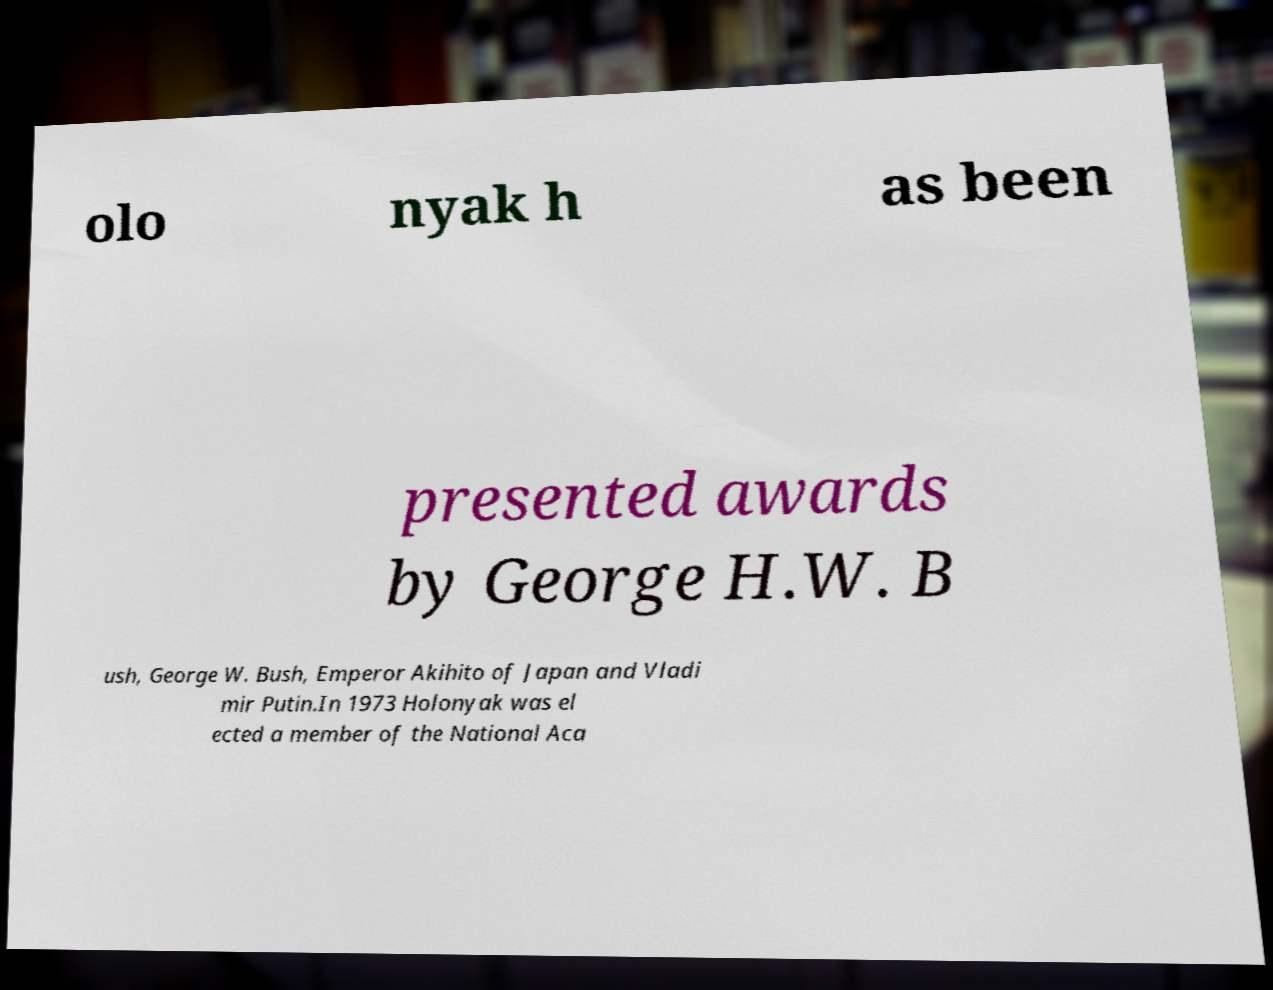What messages or text are displayed in this image? I need them in a readable, typed format. olo nyak h as been presented awards by George H.W. B ush, George W. Bush, Emperor Akihito of Japan and Vladi mir Putin.In 1973 Holonyak was el ected a member of the National Aca 